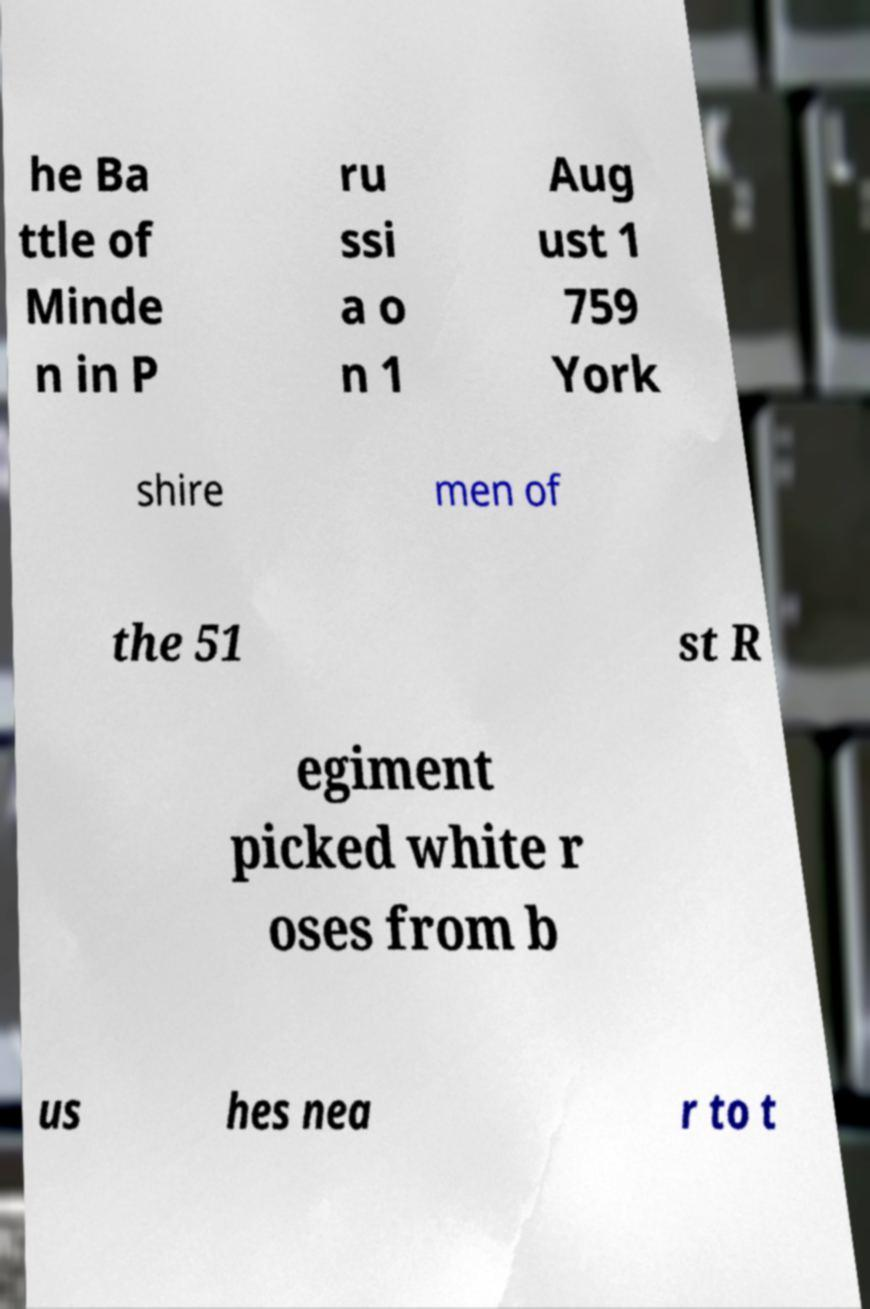Can you accurately transcribe the text from the provided image for me? he Ba ttle of Minde n in P ru ssi a o n 1 Aug ust 1 759 York shire men of the 51 st R egiment picked white r oses from b us hes nea r to t 